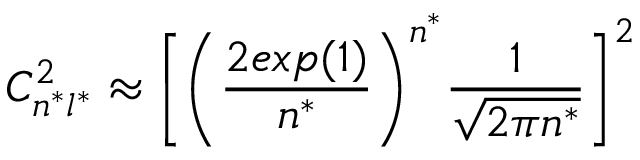<formula> <loc_0><loc_0><loc_500><loc_500>C _ { n ^ { * } l ^ { * } } ^ { 2 } \approx \left [ \left ( \frac { 2 e x p ( 1 ) } { n ^ { * } } \right ) ^ { n ^ { * } } \frac { 1 } { \sqrt { 2 \pi n ^ { * } } } \right ] ^ { 2 }</formula> 